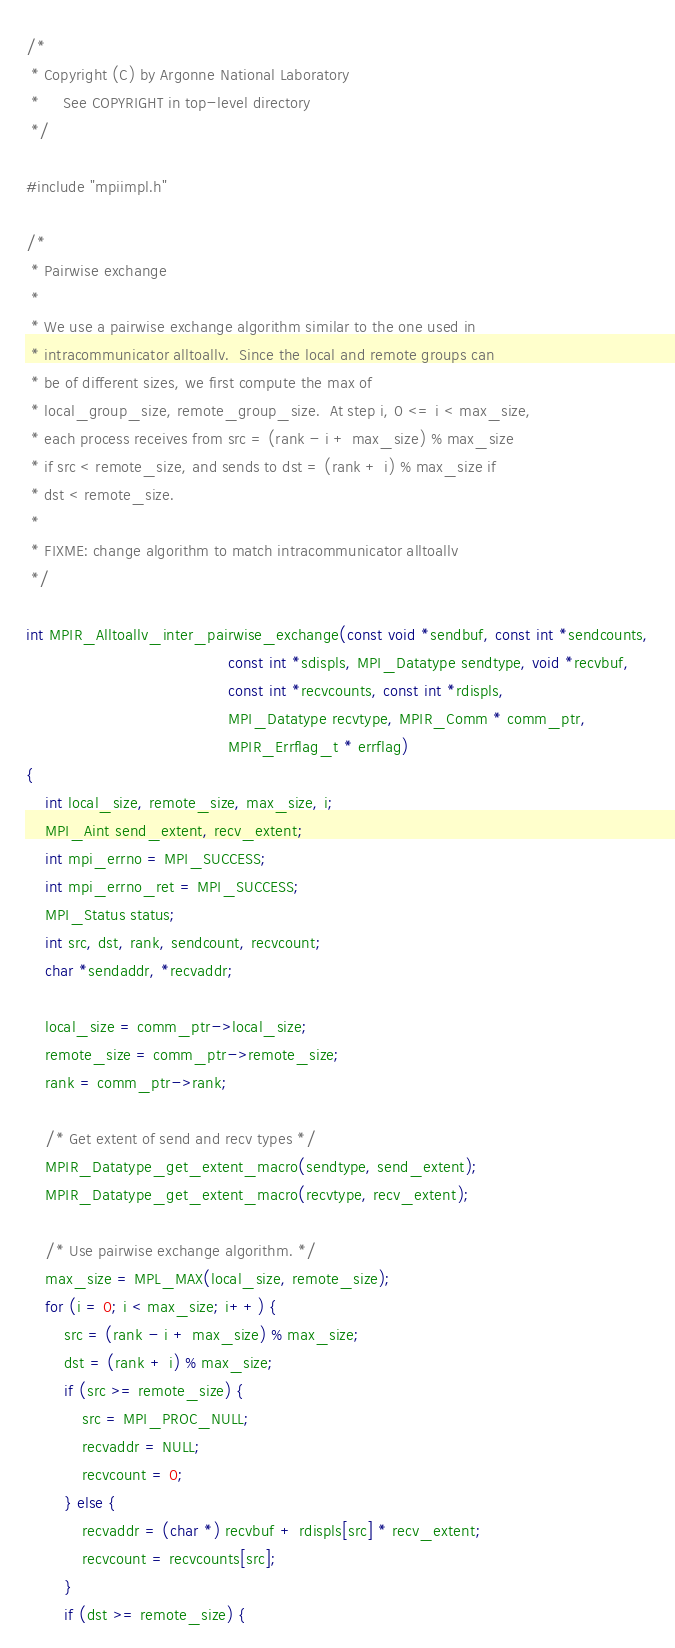Convert code to text. <code><loc_0><loc_0><loc_500><loc_500><_C_>/*
 * Copyright (C) by Argonne National Laboratory
 *     See COPYRIGHT in top-level directory
 */

#include "mpiimpl.h"

/*
 * Pairwise exchange
 *
 * We use a pairwise exchange algorithm similar to the one used in
 * intracommunicator alltoallv.  Since the local and remote groups can
 * be of different sizes, we first compute the max of
 * local_group_size, remote_group_size.  At step i, 0 <= i < max_size,
 * each process receives from src = (rank - i + max_size) % max_size
 * if src < remote_size, and sends to dst = (rank + i) % max_size if
 * dst < remote_size.
 *
 * FIXME: change algorithm to match intracommunicator alltoallv
 */

int MPIR_Alltoallv_inter_pairwise_exchange(const void *sendbuf, const int *sendcounts,
                                           const int *sdispls, MPI_Datatype sendtype, void *recvbuf,
                                           const int *recvcounts, const int *rdispls,
                                           MPI_Datatype recvtype, MPIR_Comm * comm_ptr,
                                           MPIR_Errflag_t * errflag)
{
    int local_size, remote_size, max_size, i;
    MPI_Aint send_extent, recv_extent;
    int mpi_errno = MPI_SUCCESS;
    int mpi_errno_ret = MPI_SUCCESS;
    MPI_Status status;
    int src, dst, rank, sendcount, recvcount;
    char *sendaddr, *recvaddr;

    local_size = comm_ptr->local_size;
    remote_size = comm_ptr->remote_size;
    rank = comm_ptr->rank;

    /* Get extent of send and recv types */
    MPIR_Datatype_get_extent_macro(sendtype, send_extent);
    MPIR_Datatype_get_extent_macro(recvtype, recv_extent);

    /* Use pairwise exchange algorithm. */
    max_size = MPL_MAX(local_size, remote_size);
    for (i = 0; i < max_size; i++) {
        src = (rank - i + max_size) % max_size;
        dst = (rank + i) % max_size;
        if (src >= remote_size) {
            src = MPI_PROC_NULL;
            recvaddr = NULL;
            recvcount = 0;
        } else {
            recvaddr = (char *) recvbuf + rdispls[src] * recv_extent;
            recvcount = recvcounts[src];
        }
        if (dst >= remote_size) {</code> 